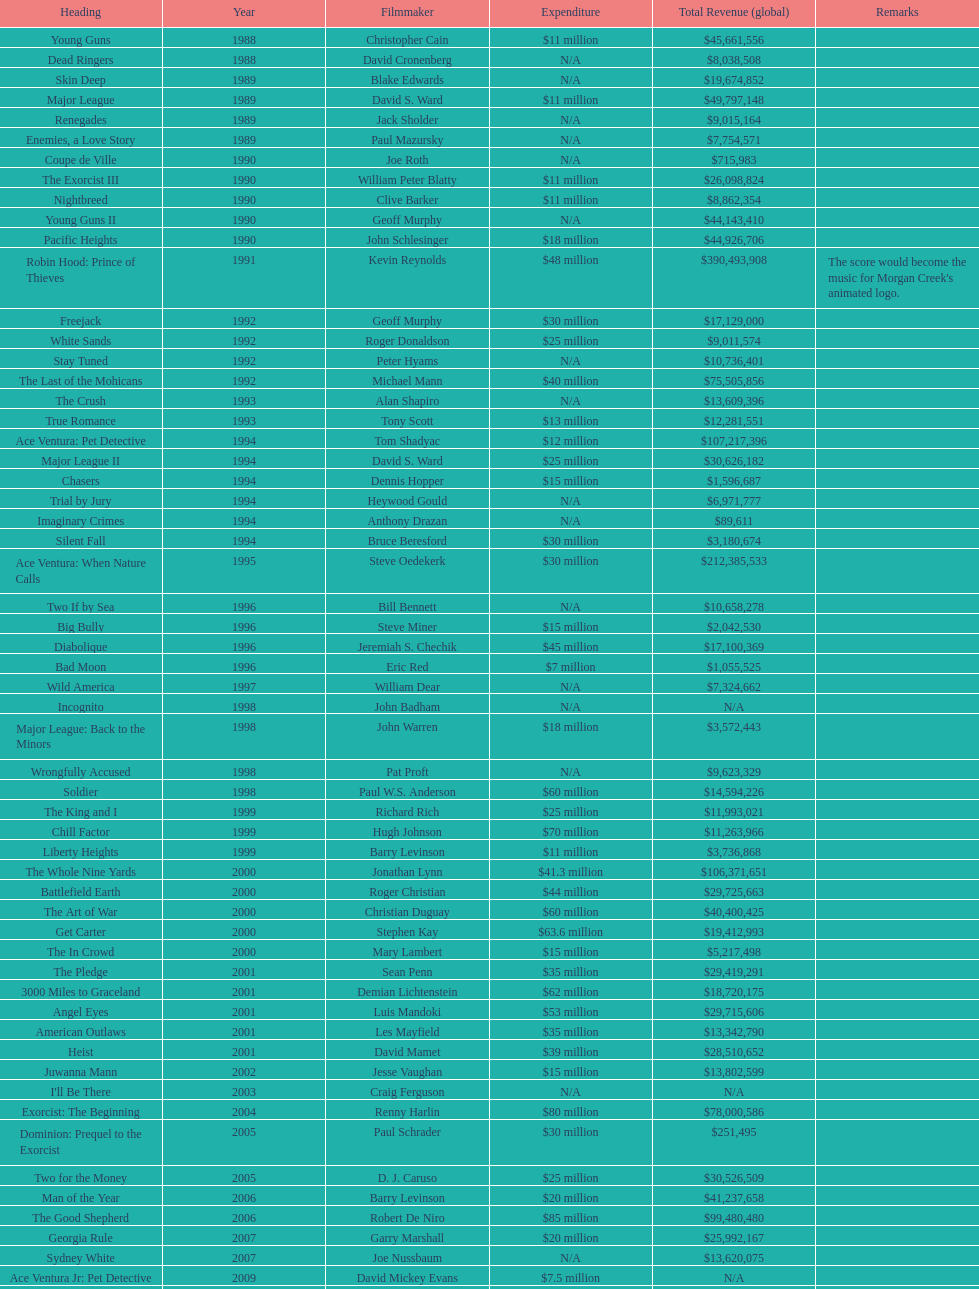What was the sole film with a 48 million dollar budget? Robin Hood: Prince of Thieves. 